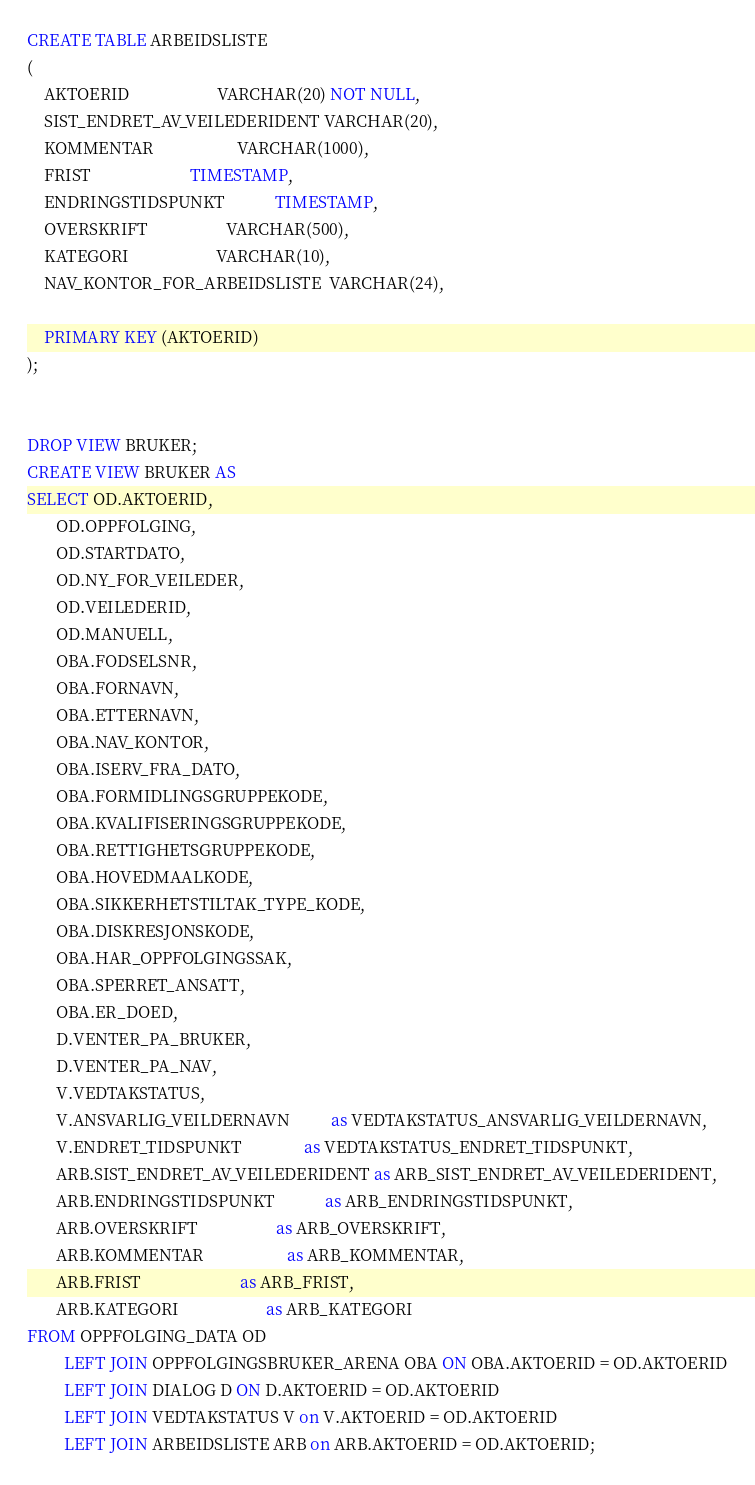<code> <loc_0><loc_0><loc_500><loc_500><_SQL_>CREATE TABLE ARBEIDSLISTE
(
    AKTOERID                     VARCHAR(20) NOT NULL,
    SIST_ENDRET_AV_VEILEDERIDENT VARCHAR(20),
    KOMMENTAR                    VARCHAR(1000),
    FRIST                        TIMESTAMP,
    ENDRINGSTIDSPUNKT            TIMESTAMP,
    OVERSKRIFT                   VARCHAR(500),
    KATEGORI                     VARCHAR(10),
    NAV_KONTOR_FOR_ARBEIDSLISTE  VARCHAR(24),

    PRIMARY KEY (AKTOERID)
);


DROP VIEW BRUKER;
CREATE VIEW BRUKER AS
SELECT OD.AKTOERID,
       OD.OPPFOLGING,
       OD.STARTDATO,
       OD.NY_FOR_VEILEDER,
       OD.VEILEDERID,
       OD.MANUELL,
       OBA.FODSELSNR,
       OBA.FORNAVN,
       OBA.ETTERNAVN,
       OBA.NAV_KONTOR,
       OBA.ISERV_FRA_DATO,
       OBA.FORMIDLINGSGRUPPEKODE,
       OBA.KVALIFISERINGSGRUPPEKODE,
       OBA.RETTIGHETSGRUPPEKODE,
       OBA.HOVEDMAALKODE,
       OBA.SIKKERHETSTILTAK_TYPE_KODE,
       OBA.DISKRESJONSKODE,
       OBA.HAR_OPPFOLGINGSSAK,
       OBA.SPERRET_ANSATT,
       OBA.ER_DOED,
       D.VENTER_PA_BRUKER,
       D.VENTER_PA_NAV,
       V.VEDTAKSTATUS,
       V.ANSVARLIG_VEILDERNAVN          as VEDTAKSTATUS_ANSVARLIG_VEILDERNAVN,
       V.ENDRET_TIDSPUNKT               as VEDTAKSTATUS_ENDRET_TIDSPUNKT,
       ARB.SIST_ENDRET_AV_VEILEDERIDENT as ARB_SIST_ENDRET_AV_VEILEDERIDENT,
       ARB.ENDRINGSTIDSPUNKT            as ARB_ENDRINGSTIDSPUNKT,
       ARB.OVERSKRIFT                   as ARB_OVERSKRIFT,
       ARB.KOMMENTAR                    as ARB_KOMMENTAR,
       ARB.FRIST                        as ARB_FRIST,
       ARB.KATEGORI                     as ARB_KATEGORI
FROM OPPFOLGING_DATA OD
         LEFT JOIN OPPFOLGINGSBRUKER_ARENA OBA ON OBA.AKTOERID = OD.AKTOERID
         LEFT JOIN DIALOG D ON D.AKTOERID = OD.AKTOERID
         LEFT JOIN VEDTAKSTATUS V on V.AKTOERID = OD.AKTOERID
         LEFT JOIN ARBEIDSLISTE ARB on ARB.AKTOERID = OD.AKTOERID;
</code> 